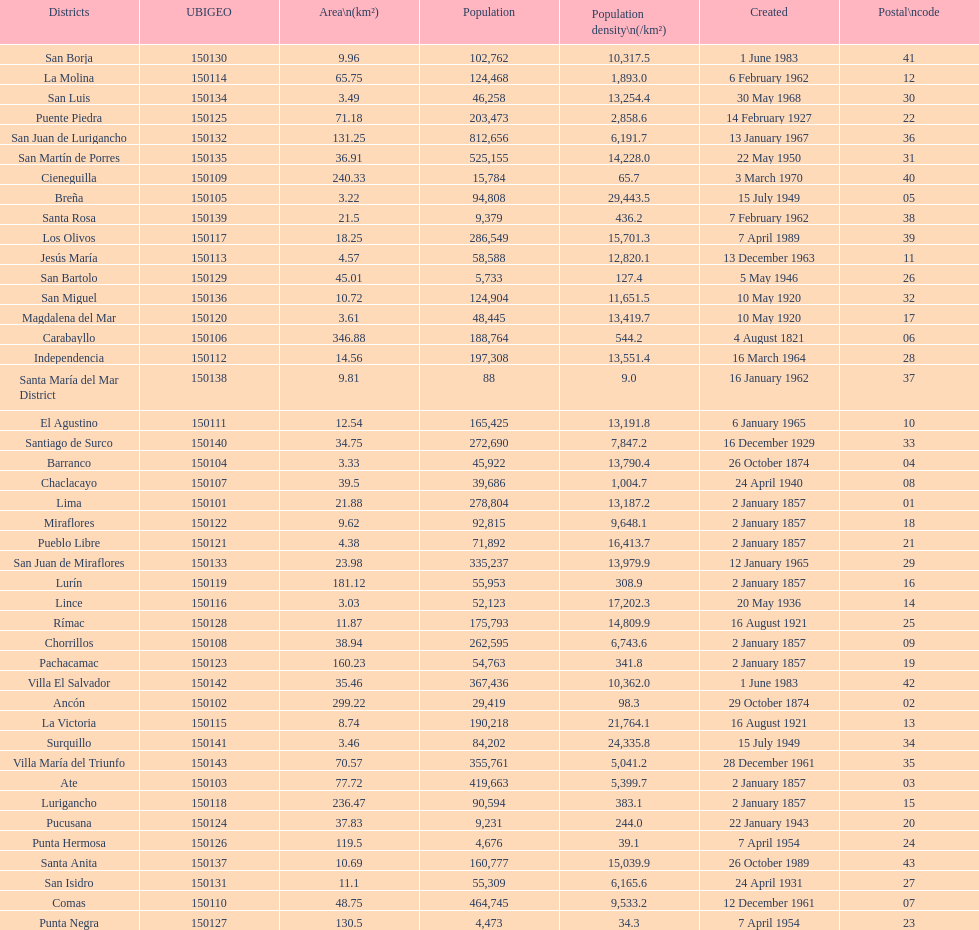What district has the least amount of population? Santa María del Mar District. 